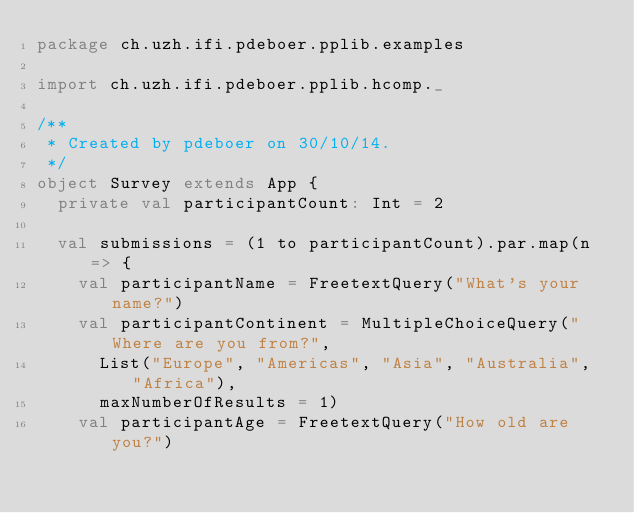<code> <loc_0><loc_0><loc_500><loc_500><_Scala_>package ch.uzh.ifi.pdeboer.pplib.examples

import ch.uzh.ifi.pdeboer.pplib.hcomp._

/**
 * Created by pdeboer on 30/10/14.
 */
object Survey extends App {
	private val participantCount: Int = 2

	val submissions = (1 to participantCount).par.map(n => {
		val participantName = FreetextQuery("What's your name?")
		val participantContinent = MultipleChoiceQuery("Where are you from?",
			List("Europe", "Americas", "Asia", "Australia", "Africa"),
			maxNumberOfResults = 1)
		val participantAge = FreetextQuery("How old are you?")
</code> 